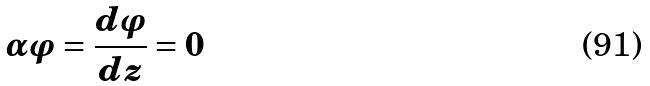Convert formula to latex. <formula><loc_0><loc_0><loc_500><loc_500>\alpha \varphi = \frac { d \varphi } { d z } = 0</formula> 